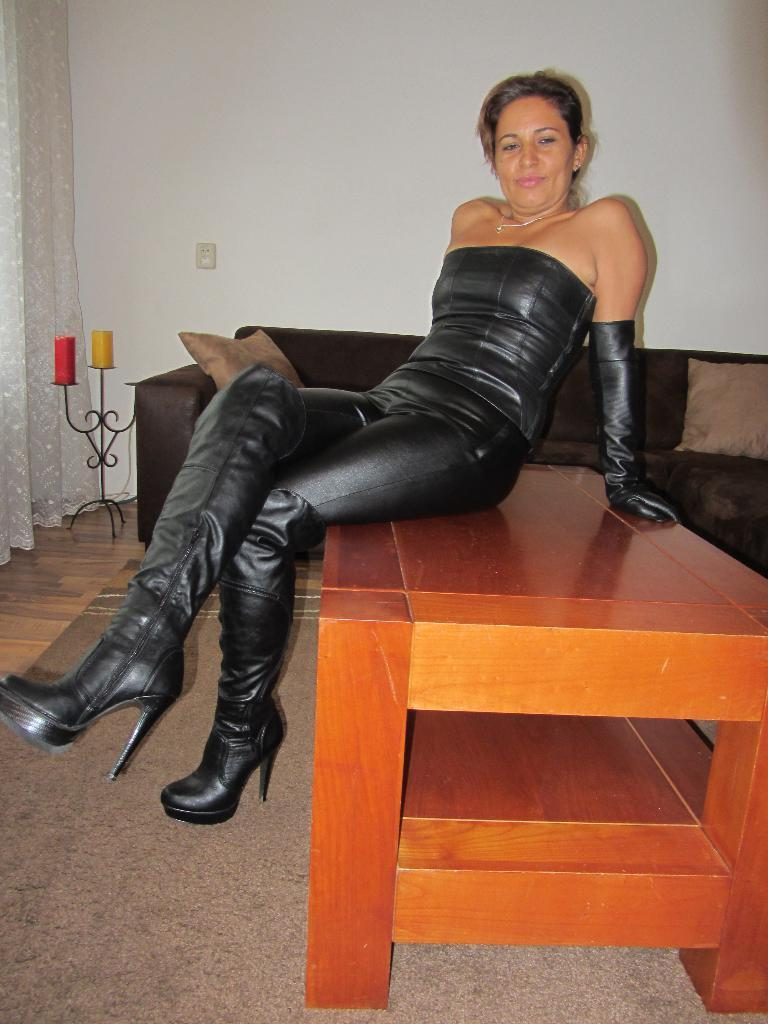Who is present in the image? There is a woman in the image. What is the woman doing in the image? The woman is smiling in the image. Where is the woman sitting in the image? The woman is sitting on a table in the image. What is near the table in the image? There is a sofa near the table in the image. What is on the sofa in the image? There are pillows on the sofa in the image. What other objects can be seen in the image? There are candles in the image. What is visible in the background of the image? There is a curtain and a wall in the background of the image. How does the woman plan to travel to the moon in the image? There is no mention of the moon or any travel plans in the image. The woman is simply sitting on a table and smiling. 